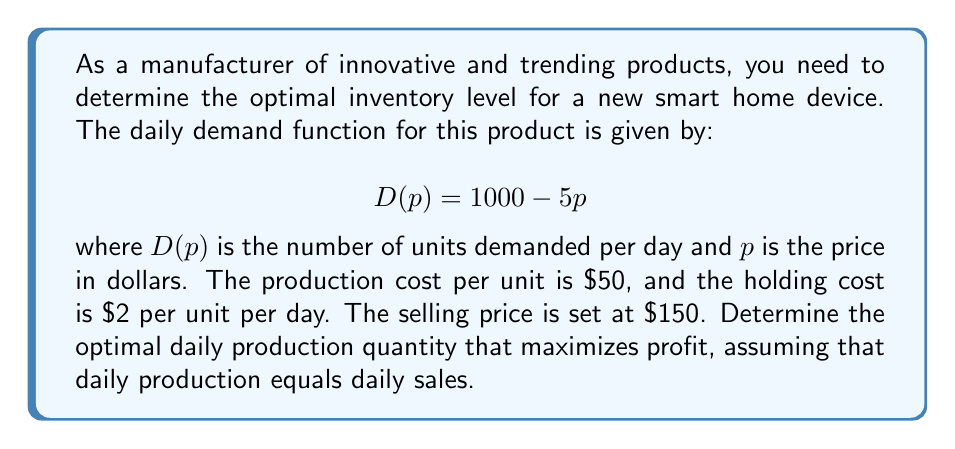Could you help me with this problem? To solve this problem, we'll follow these steps:

1. Calculate the daily demand at the given price:
   $$ D(150) = 1000 - 5(150) = 250 \text{ units} $$

2. The profit function is given by:
   $$ \text{Profit} = \text{Revenue} - \text{Production Cost} - \text{Holding Cost} $$
   $$ \pi(q) = 150q - 50q - 2q = 98q $$
   where $q$ is the daily production quantity.

3. Since we assume daily production equals daily sales, we can set $q = 250$.

4. Calculate the daily profit:
   $$ \pi(250) = 98(250) = 24,500 $$

Therefore, the optimal daily production quantity that maximizes profit is 250 units, resulting in a daily profit of $24,500.

Note: In this simplified model, we assume that the manufacturer can perfectly match production to demand. In reality, there might be additional factors to consider, such as minimum order quantities, lead times, and demand fluctuations.
Answer: The optimal daily production quantity is 250 units, generating a daily profit of $24,500. 